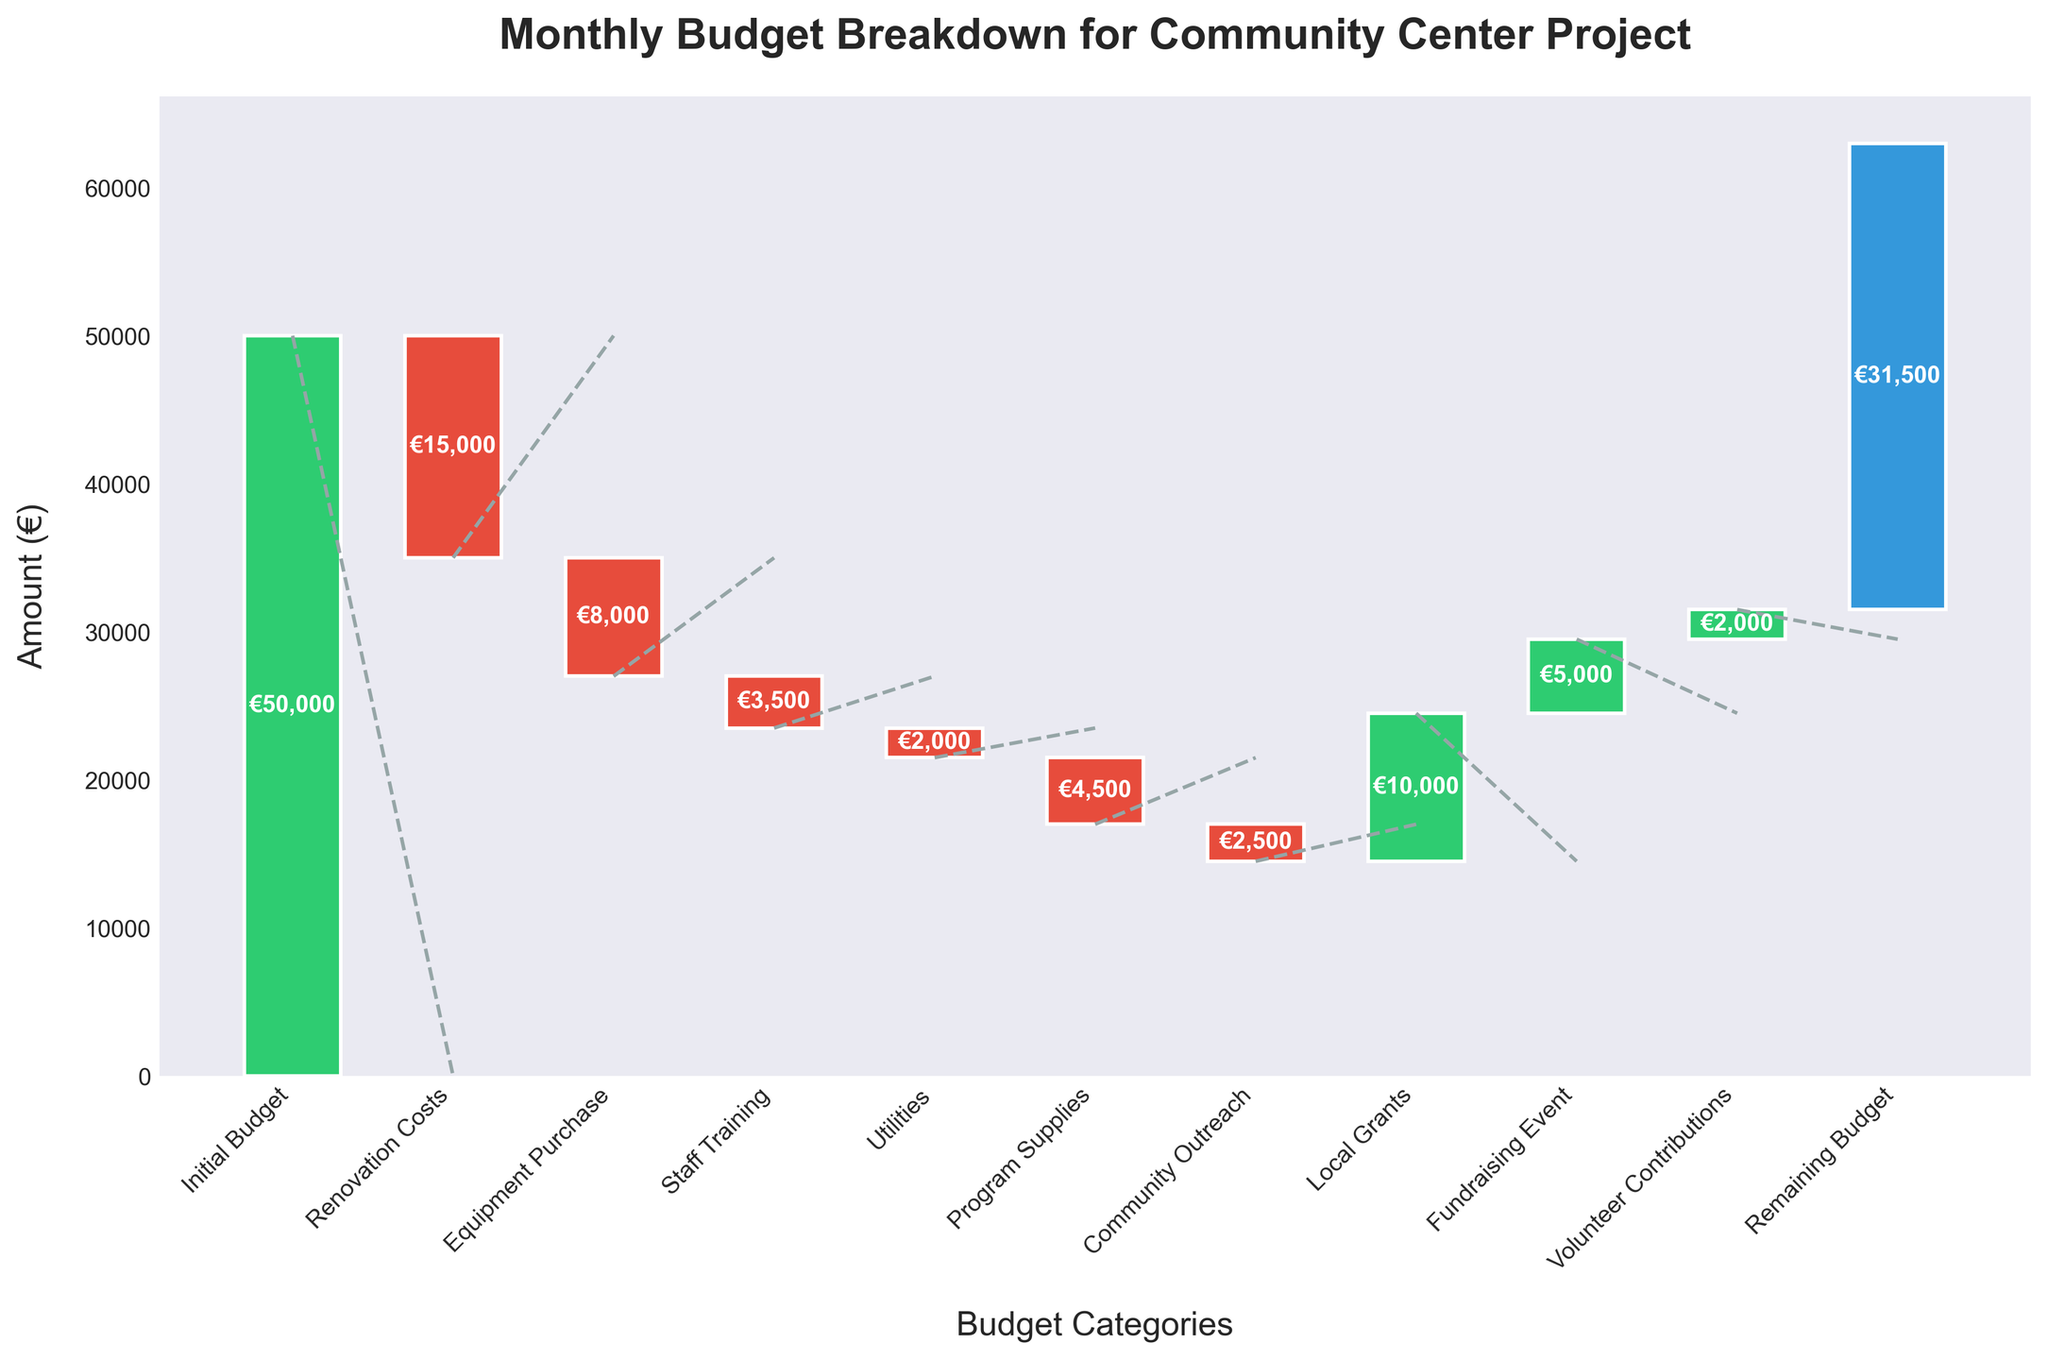What's the title of the chart? The title of the chart is usually located at the top, it provides an overview of the content and purpose of the figure.
Answer: Monthly Budget Breakdown for Community Center Project How much is the initial budget for the project? Find the bar corresponding to 'Initial Budget' and read the associated value.
Answer: €50,000 Which category has the largest negative impact on the budget? Identify the category with the largest downward bar.
Answer: Renovation Costs What is the remaining budget after all expenses and additional contributions? Look at the last bar labeled 'Remaining Budget' to find the final value.
Answer: €31,500 How much more was spent on Equipment Purchase compared to Staff Training? Subtract the amount spent on Staff Training from the amount spent on Equipment Purchase.
Answer: €4,500 Which categories contribute positively to the budget? Identify the bars with positive values: they are in green.
Answer: Local Grants, Fundraising Event, Volunteer Contributions How does the amount from Local Grants compare to the amount from Fundraising Event? Compare the lengths of the bars for Local Grants and Fundraising Event.
Answer: Local Grants: €10,000, Fundraising Event: €5,000 What is the total expenditure for Renovation Costs, Equipment Purchase, and Staff Training combined? Sum the values for Renovation Costs, Equipment Purchase, and Staff Training.
Answer: €26,500 Out of Utilities and Community Outreach, which has the lower expenditure? Compare the heights of the bars for Utilities and Community Outreach.
Answer: Utilities What was the net increase or decrease in budget after accounting for all categories except the initial budget? Sum all contributions and subtract all expenses, excluding the initial budget. The net change = (Local Grants + Fundraising Event + Volunteer Contributions) - (Renovation Costs + Equipment Purchase + Staff Training + Utilities + Program Supplies + Community Outreach). Local Grants: €10,000 + Fundraising Event: €5,000 + Volunteer Contributions: €2,000 - Renovation Costs: €15,000 - Equipment Purchase: €8,000 - Staff Training: €3,500 - Utilities: €2,000 - Program Supplies: €4,500 - Community Outreach: €2,500 = Net change: -€18,500
Answer: €-18,000 